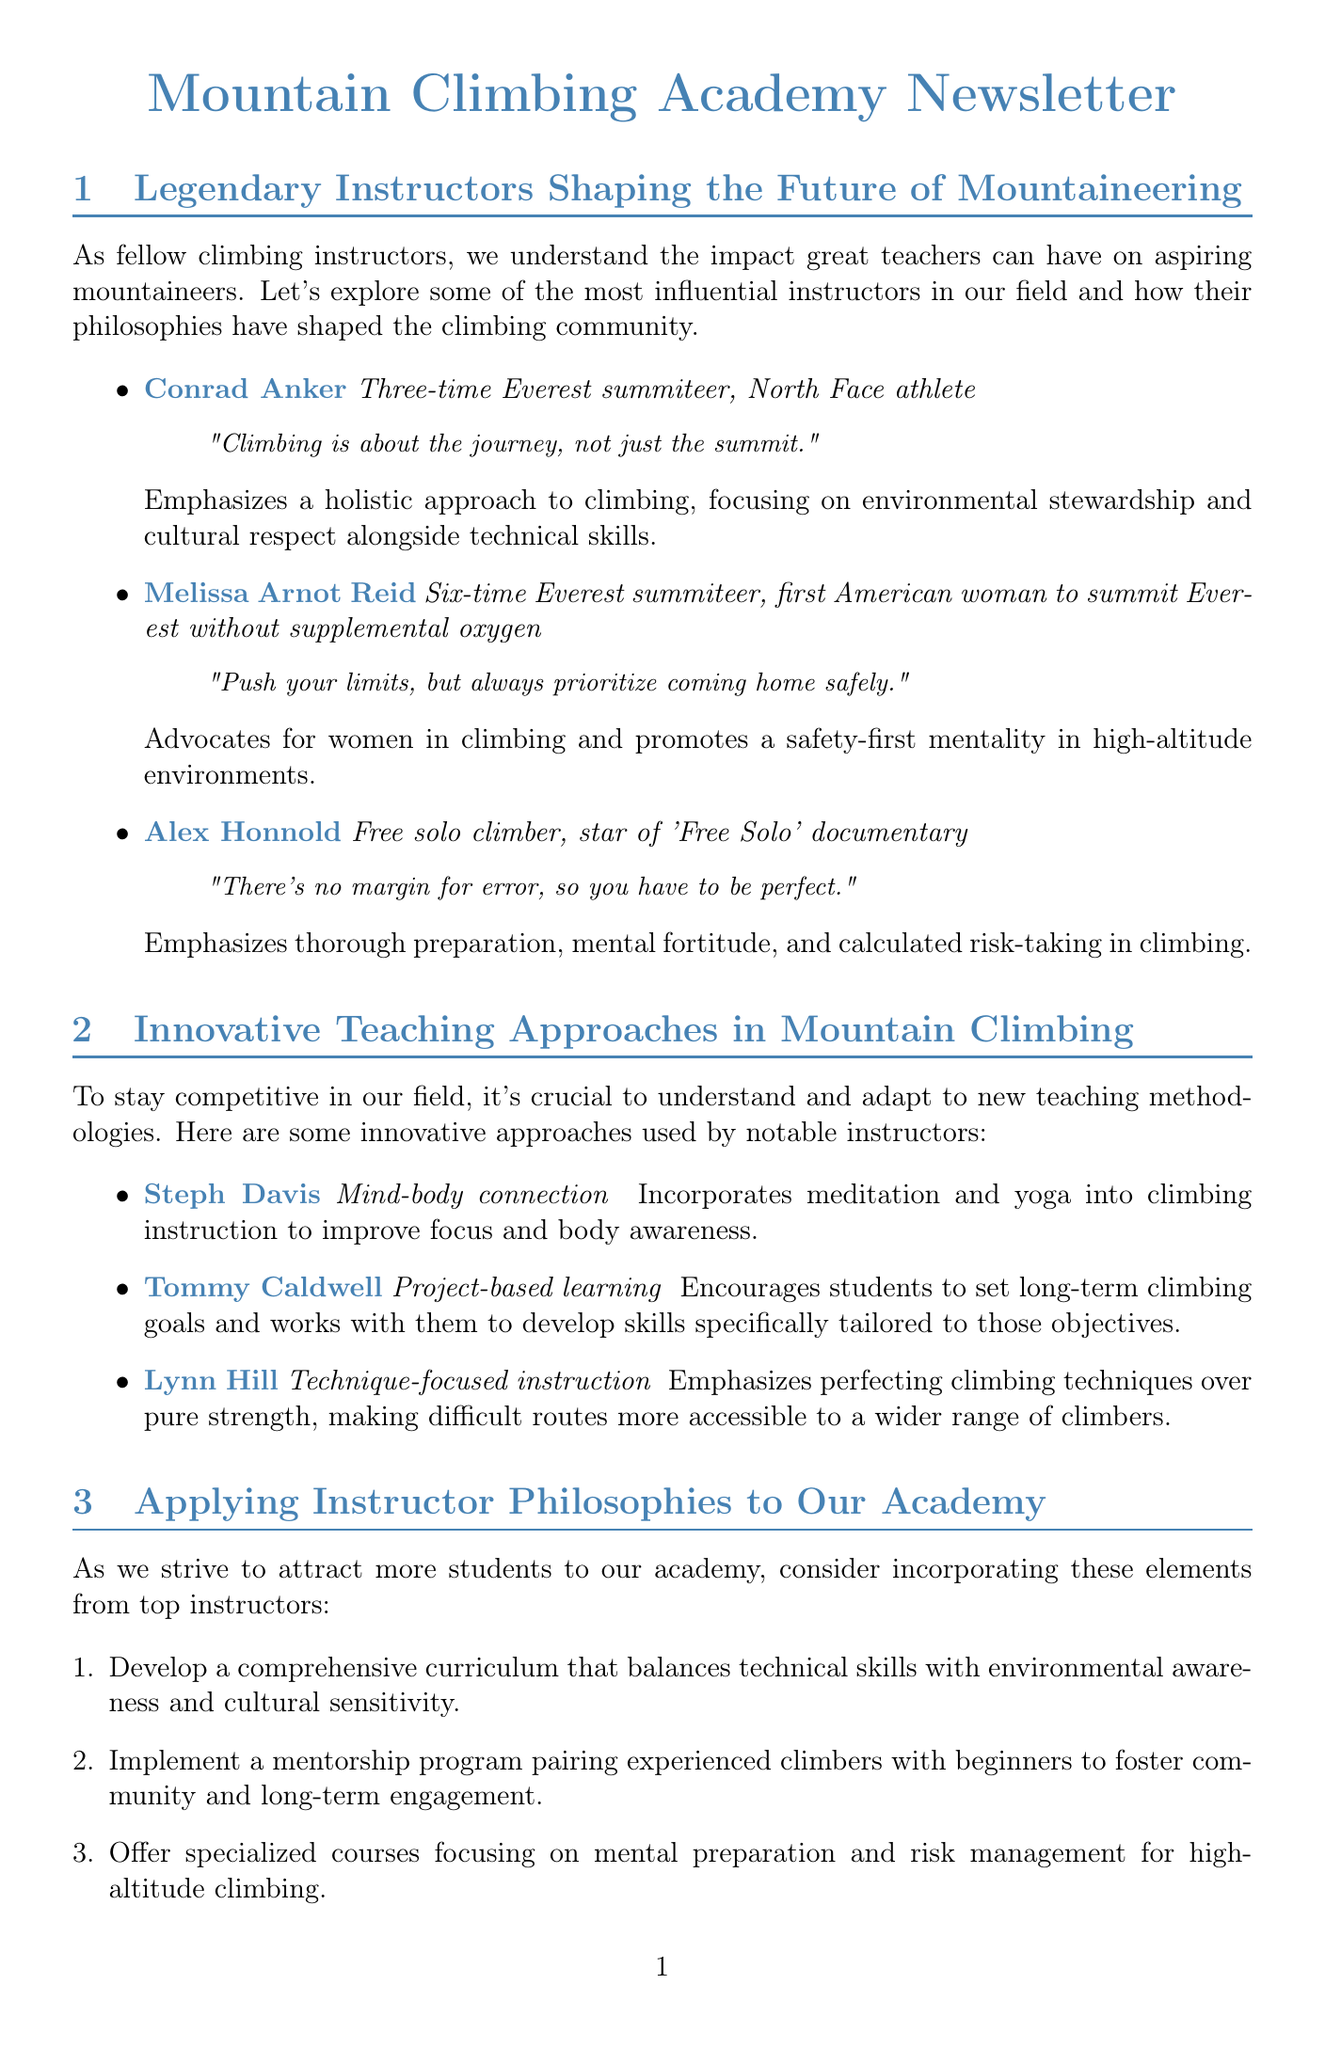what is the name of the instructor known for a holistic approach? Conrad Anker emphasizes a holistic approach to climbing, integrating environmental stewardship and cultural respect.
Answer: Conrad Anker how many times has Melissa Arnot Reid summited Everest? Melissa Arnot Reid's accolades include being a six-time Everest summiteer.
Answer: six what innovative teaching method does Steph Davis use? Steph Davis incorporates meditation and yoga into climbing instruction to improve focus and body awareness.
Answer: Mind-body connection which instructor promotes a safety-first mentality? Melissa Arnot Reid advocates for women in climbing and a safety-first mentality in high-altitude environments.
Answer: Melissa Arnot Reid what is the date for the AMGA Alpine Guide Course? The AMGA Alpine Guide Course takes place from August 15-28, 2023.
Answer: August 15-28, 2023 how many recommendations are listed for applying instructor philosophies? The document includes five recommendations for applying instructor philosophies to the academy.
Answer: five what is a focus of the upcoming NOLS Wilderness First Responder program? The focus of the NOLS Wilderness First Responder program is on advanced wilderness medical training for climbing instructors.
Answer: Advanced wilderness medical training who is known for technique-focused instruction? Lynn Hill emphasizes perfecting climbing techniques over pure strength for better accessibility.
Answer: Lynn Hill 